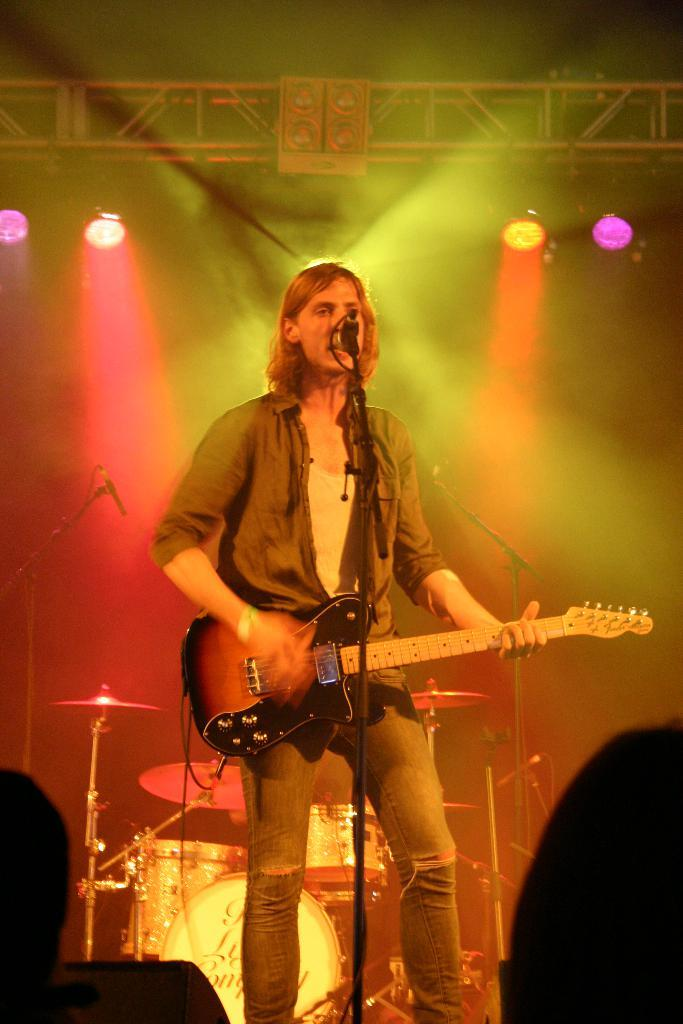Who is the main subject in the image? There is a woman in the image. What is the woman doing in the image? The woman is singing and playing a guitar. What object is the woman holding while singing? The woman is holding a microphone. What other musical instrument is present in the image? There is a drum set in the image. How is the scene illuminated in the image? The lights are focused on the scene. What type of bushes can be seen growing around the drum set in the image? There are no bushes present in the image; it features a woman singing and playing a guitar, holding a microphone, and a drum set in a well-lit scene. 